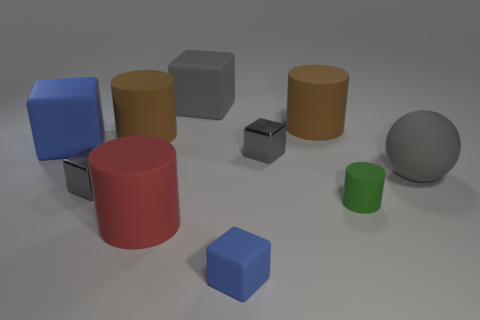Is the size of the blue thing behind the green cylinder the same as the small green rubber cylinder?
Offer a very short reply. No. Are there the same number of blue matte objects that are on the right side of the large rubber sphere and big matte things?
Give a very brief answer. No. How many cylinders are gray metallic things or big brown things?
Provide a succinct answer. 2. What is the color of the tiny block that is made of the same material as the big red cylinder?
Offer a very short reply. Blue. Is the material of the big gray cube the same as the big gray thing right of the tiny green matte cylinder?
Your response must be concise. Yes. What number of objects are large brown rubber objects or large gray rubber spheres?
Make the answer very short. 3. What is the material of the big object that is the same color as the large matte sphere?
Ensure brevity in your answer.  Rubber. Are there any shiny objects that have the same shape as the tiny blue rubber thing?
Keep it short and to the point. Yes. What number of big red objects are left of the big blue cube?
Keep it short and to the point. 0. What is the material of the brown cylinder left of the small rubber object in front of the green matte thing?
Make the answer very short. Rubber. 